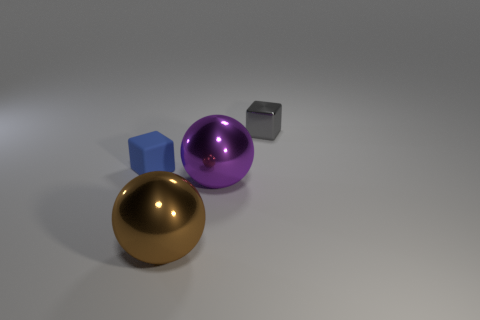Can you guess what the lighting setup might be based on the shadows? Based on the shadows and highlights in the image, the lighting setup likely consists of a strong, relatively centralized light source above the objects, creating sharp, defined shadows that are mostly beneath and to the right of each object. This suggests a single key light could be used, simulating an effect similar to sunlight or a focused indoor light.  Can the shadows give us any information about the shape and size of the light source? Yes, the shadows provide clues about the light source. The sharpness and clarity of the shadows indicate that the light source is probably smaller in size relative to the objects, which allows for more defined shadows. If the light source were larger or more diffused, the shadows would be softer and less distinct. However, without more context, we can't determine the exact shape of the light source. 